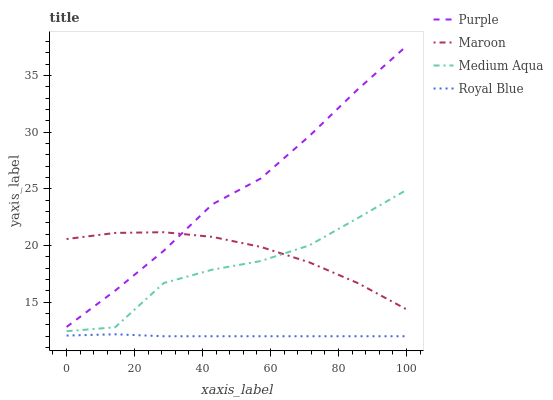Does Royal Blue have the minimum area under the curve?
Answer yes or no. Yes. Does Purple have the maximum area under the curve?
Answer yes or no. Yes. Does Medium Aqua have the minimum area under the curve?
Answer yes or no. No. Does Medium Aqua have the maximum area under the curve?
Answer yes or no. No. Is Royal Blue the smoothest?
Answer yes or no. Yes. Is Medium Aqua the roughest?
Answer yes or no. Yes. Is Medium Aqua the smoothest?
Answer yes or no. No. Is Royal Blue the roughest?
Answer yes or no. No. Does Royal Blue have the lowest value?
Answer yes or no. Yes. Does Medium Aqua have the lowest value?
Answer yes or no. No. Does Purple have the highest value?
Answer yes or no. Yes. Does Medium Aqua have the highest value?
Answer yes or no. No. Is Royal Blue less than Medium Aqua?
Answer yes or no. Yes. Is Purple greater than Royal Blue?
Answer yes or no. Yes. Does Maroon intersect Medium Aqua?
Answer yes or no. Yes. Is Maroon less than Medium Aqua?
Answer yes or no. No. Is Maroon greater than Medium Aqua?
Answer yes or no. No. Does Royal Blue intersect Medium Aqua?
Answer yes or no. No. 